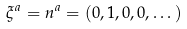Convert formula to latex. <formula><loc_0><loc_0><loc_500><loc_500>\xi ^ { a } = n ^ { a } = ( 0 , 1 , 0 , 0 , \dots )</formula> 